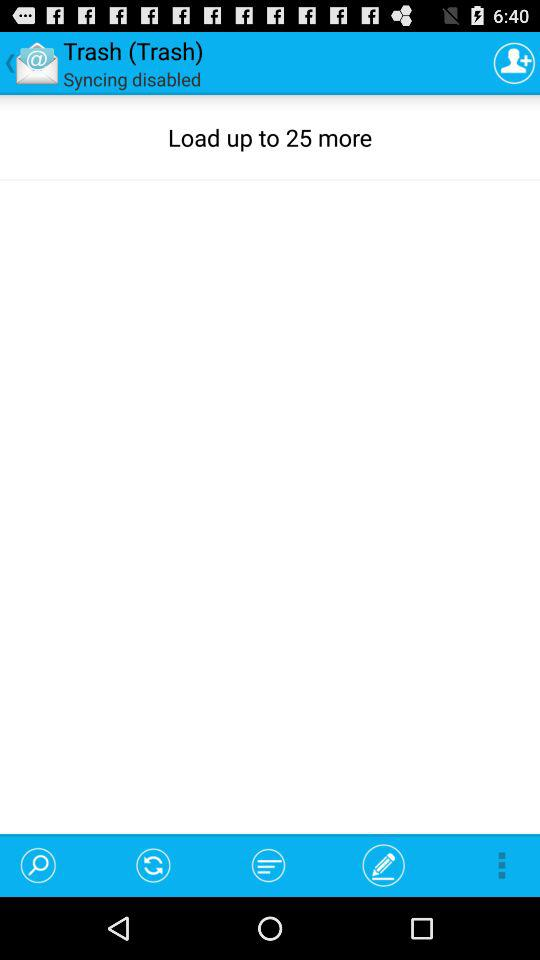What is the name of the application? The name of the application is "All Email Services Login". 